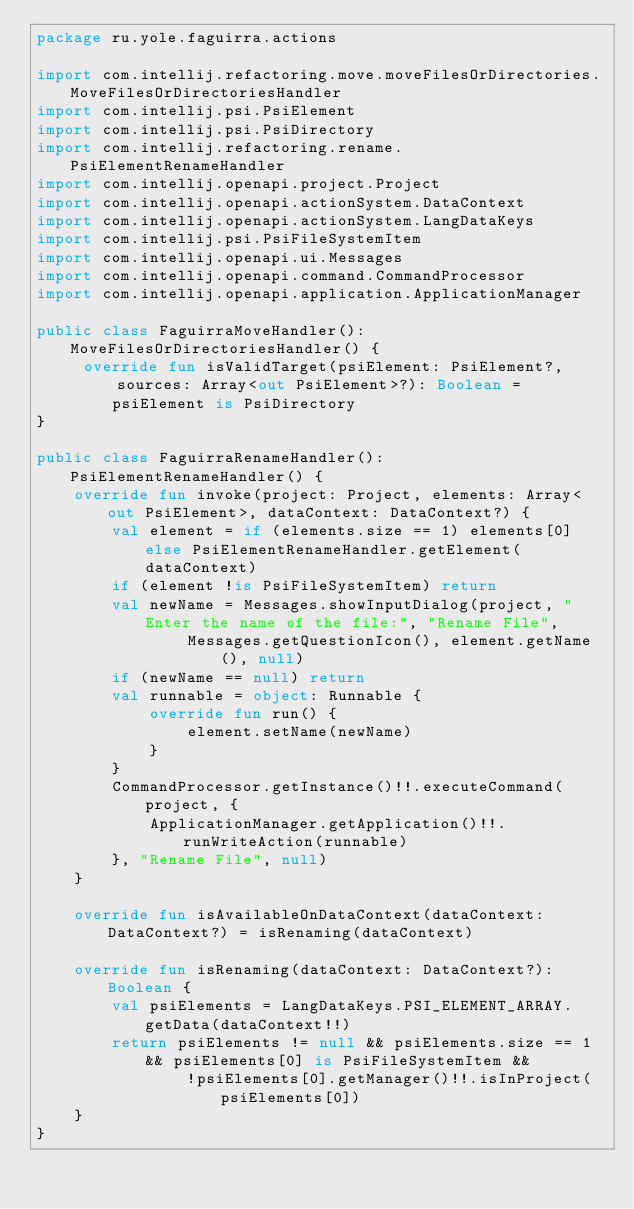<code> <loc_0><loc_0><loc_500><loc_500><_Kotlin_>package ru.yole.faguirra.actions

import com.intellij.refactoring.move.moveFilesOrDirectories.MoveFilesOrDirectoriesHandler
import com.intellij.psi.PsiElement
import com.intellij.psi.PsiDirectory
import com.intellij.refactoring.rename.PsiElementRenameHandler
import com.intellij.openapi.project.Project
import com.intellij.openapi.actionSystem.DataContext
import com.intellij.openapi.actionSystem.LangDataKeys
import com.intellij.psi.PsiFileSystemItem
import com.intellij.openapi.ui.Messages
import com.intellij.openapi.command.CommandProcessor
import com.intellij.openapi.application.ApplicationManager

public class FaguirraMoveHandler(): MoveFilesOrDirectoriesHandler() {
     override fun isValidTarget(psiElement: PsiElement?, sources: Array<out PsiElement>?): Boolean =
        psiElement is PsiDirectory
}

public class FaguirraRenameHandler(): PsiElementRenameHandler() {
    override fun invoke(project: Project, elements: Array<out PsiElement>, dataContext: DataContext?) {
        val element = if (elements.size == 1) elements[0] else PsiElementRenameHandler.getElement(dataContext)
        if (element !is PsiFileSystemItem) return
        val newName = Messages.showInputDialog(project, "Enter the name of the file:", "Rename File",
                Messages.getQuestionIcon(), element.getName(), null)
        if (newName == null) return
        val runnable = object: Runnable {
            override fun run() {
                element.setName(newName)
            }
        }
        CommandProcessor.getInstance()!!.executeCommand(project, {
            ApplicationManager.getApplication()!!.runWriteAction(runnable)
        }, "Rename File", null)
    }

    override fun isAvailableOnDataContext(dataContext: DataContext?) = isRenaming(dataContext)

    override fun isRenaming(dataContext: DataContext?): Boolean {
        val psiElements = LangDataKeys.PSI_ELEMENT_ARRAY.getData(dataContext!!)
        return psiElements != null && psiElements.size == 1 && psiElements[0] is PsiFileSystemItem &&
                !psiElements[0].getManager()!!.isInProject(psiElements[0])
    }
}
</code> 